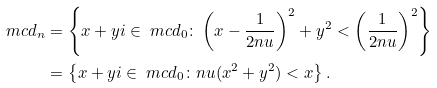<formula> <loc_0><loc_0><loc_500><loc_500>\ m c d _ { n } & = \left \{ x + y i \in \ m c d _ { 0 } \colon \left ( x - \frac { 1 } { 2 n u } \right ) ^ { 2 } + y ^ { 2 } < \left ( \frac { 1 } { 2 n u } \right ) ^ { 2 } \right \} \\ & = \left \{ x + y i \in \ m c d _ { 0 } \colon n u ( x ^ { 2 } + y ^ { 2 } ) < x \right \} .</formula> 